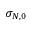Convert formula to latex. <formula><loc_0><loc_0><loc_500><loc_500>\sigma _ { N , 0 }</formula> 